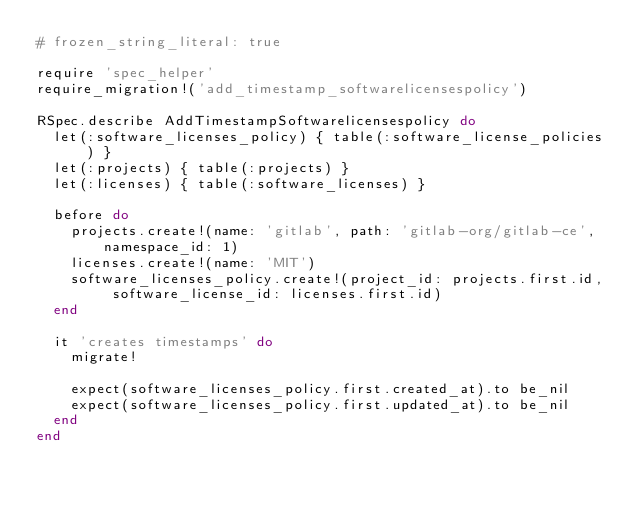Convert code to text. <code><loc_0><loc_0><loc_500><loc_500><_Ruby_># frozen_string_literal: true

require 'spec_helper'
require_migration!('add_timestamp_softwarelicensespolicy')

RSpec.describe AddTimestampSoftwarelicensespolicy do
  let(:software_licenses_policy) { table(:software_license_policies) }
  let(:projects) { table(:projects) }
  let(:licenses) { table(:software_licenses) }

  before do
    projects.create!(name: 'gitlab', path: 'gitlab-org/gitlab-ce', namespace_id: 1)
    licenses.create!(name: 'MIT')
    software_licenses_policy.create!(project_id: projects.first.id, software_license_id: licenses.first.id)
  end

  it 'creates timestamps' do
    migrate!

    expect(software_licenses_policy.first.created_at).to be_nil
    expect(software_licenses_policy.first.updated_at).to be_nil
  end
end
</code> 